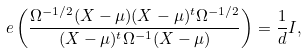Convert formula to latex. <formula><loc_0><loc_0><loc_500><loc_500>\ e \left ( \frac { \Omega ^ { - 1 / 2 } ( X - \mu ) ( X - \mu ) ^ { t } \Omega ^ { - 1 / 2 } } { ( X - \mu ) ^ { t } \Omega ^ { - 1 } ( X - \mu ) } \right ) = \frac { 1 } { d } I ,</formula> 